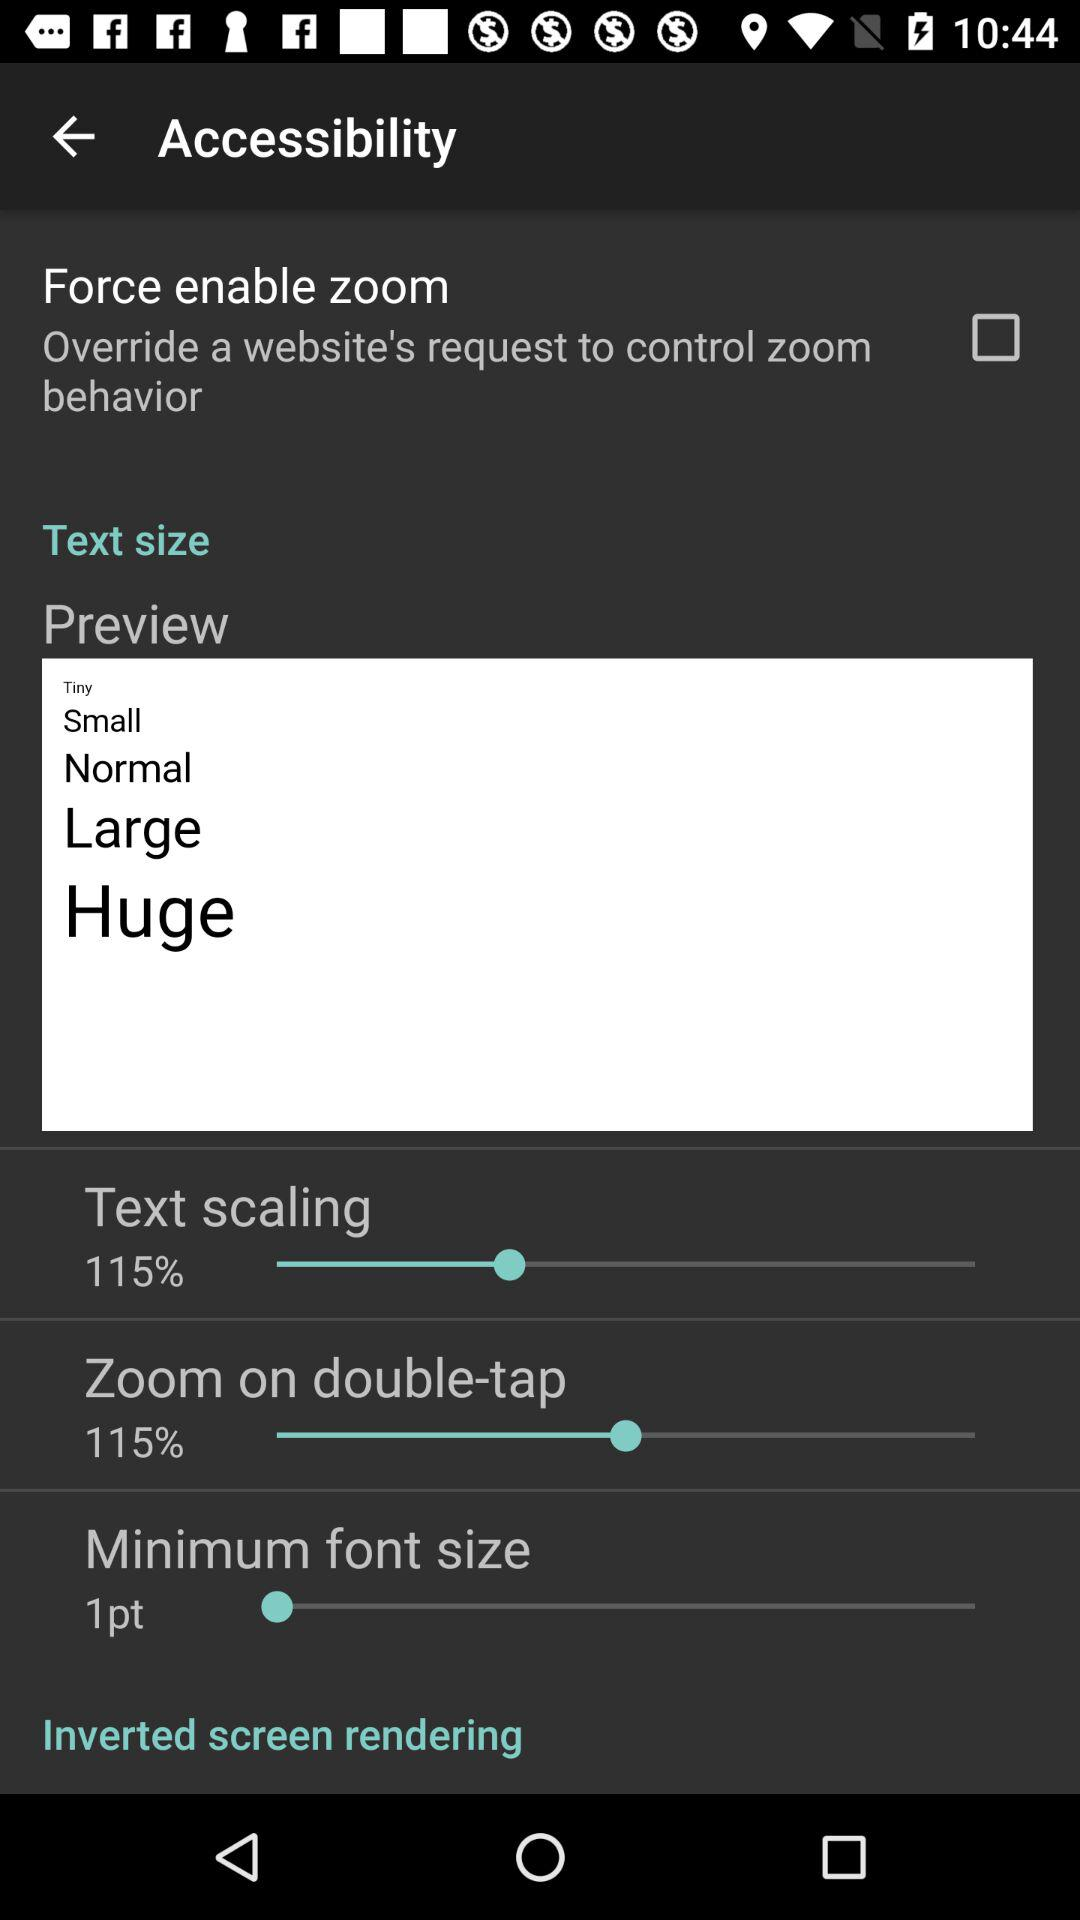What is the percentage of text scaling? The percentage of text scaling is 115. 